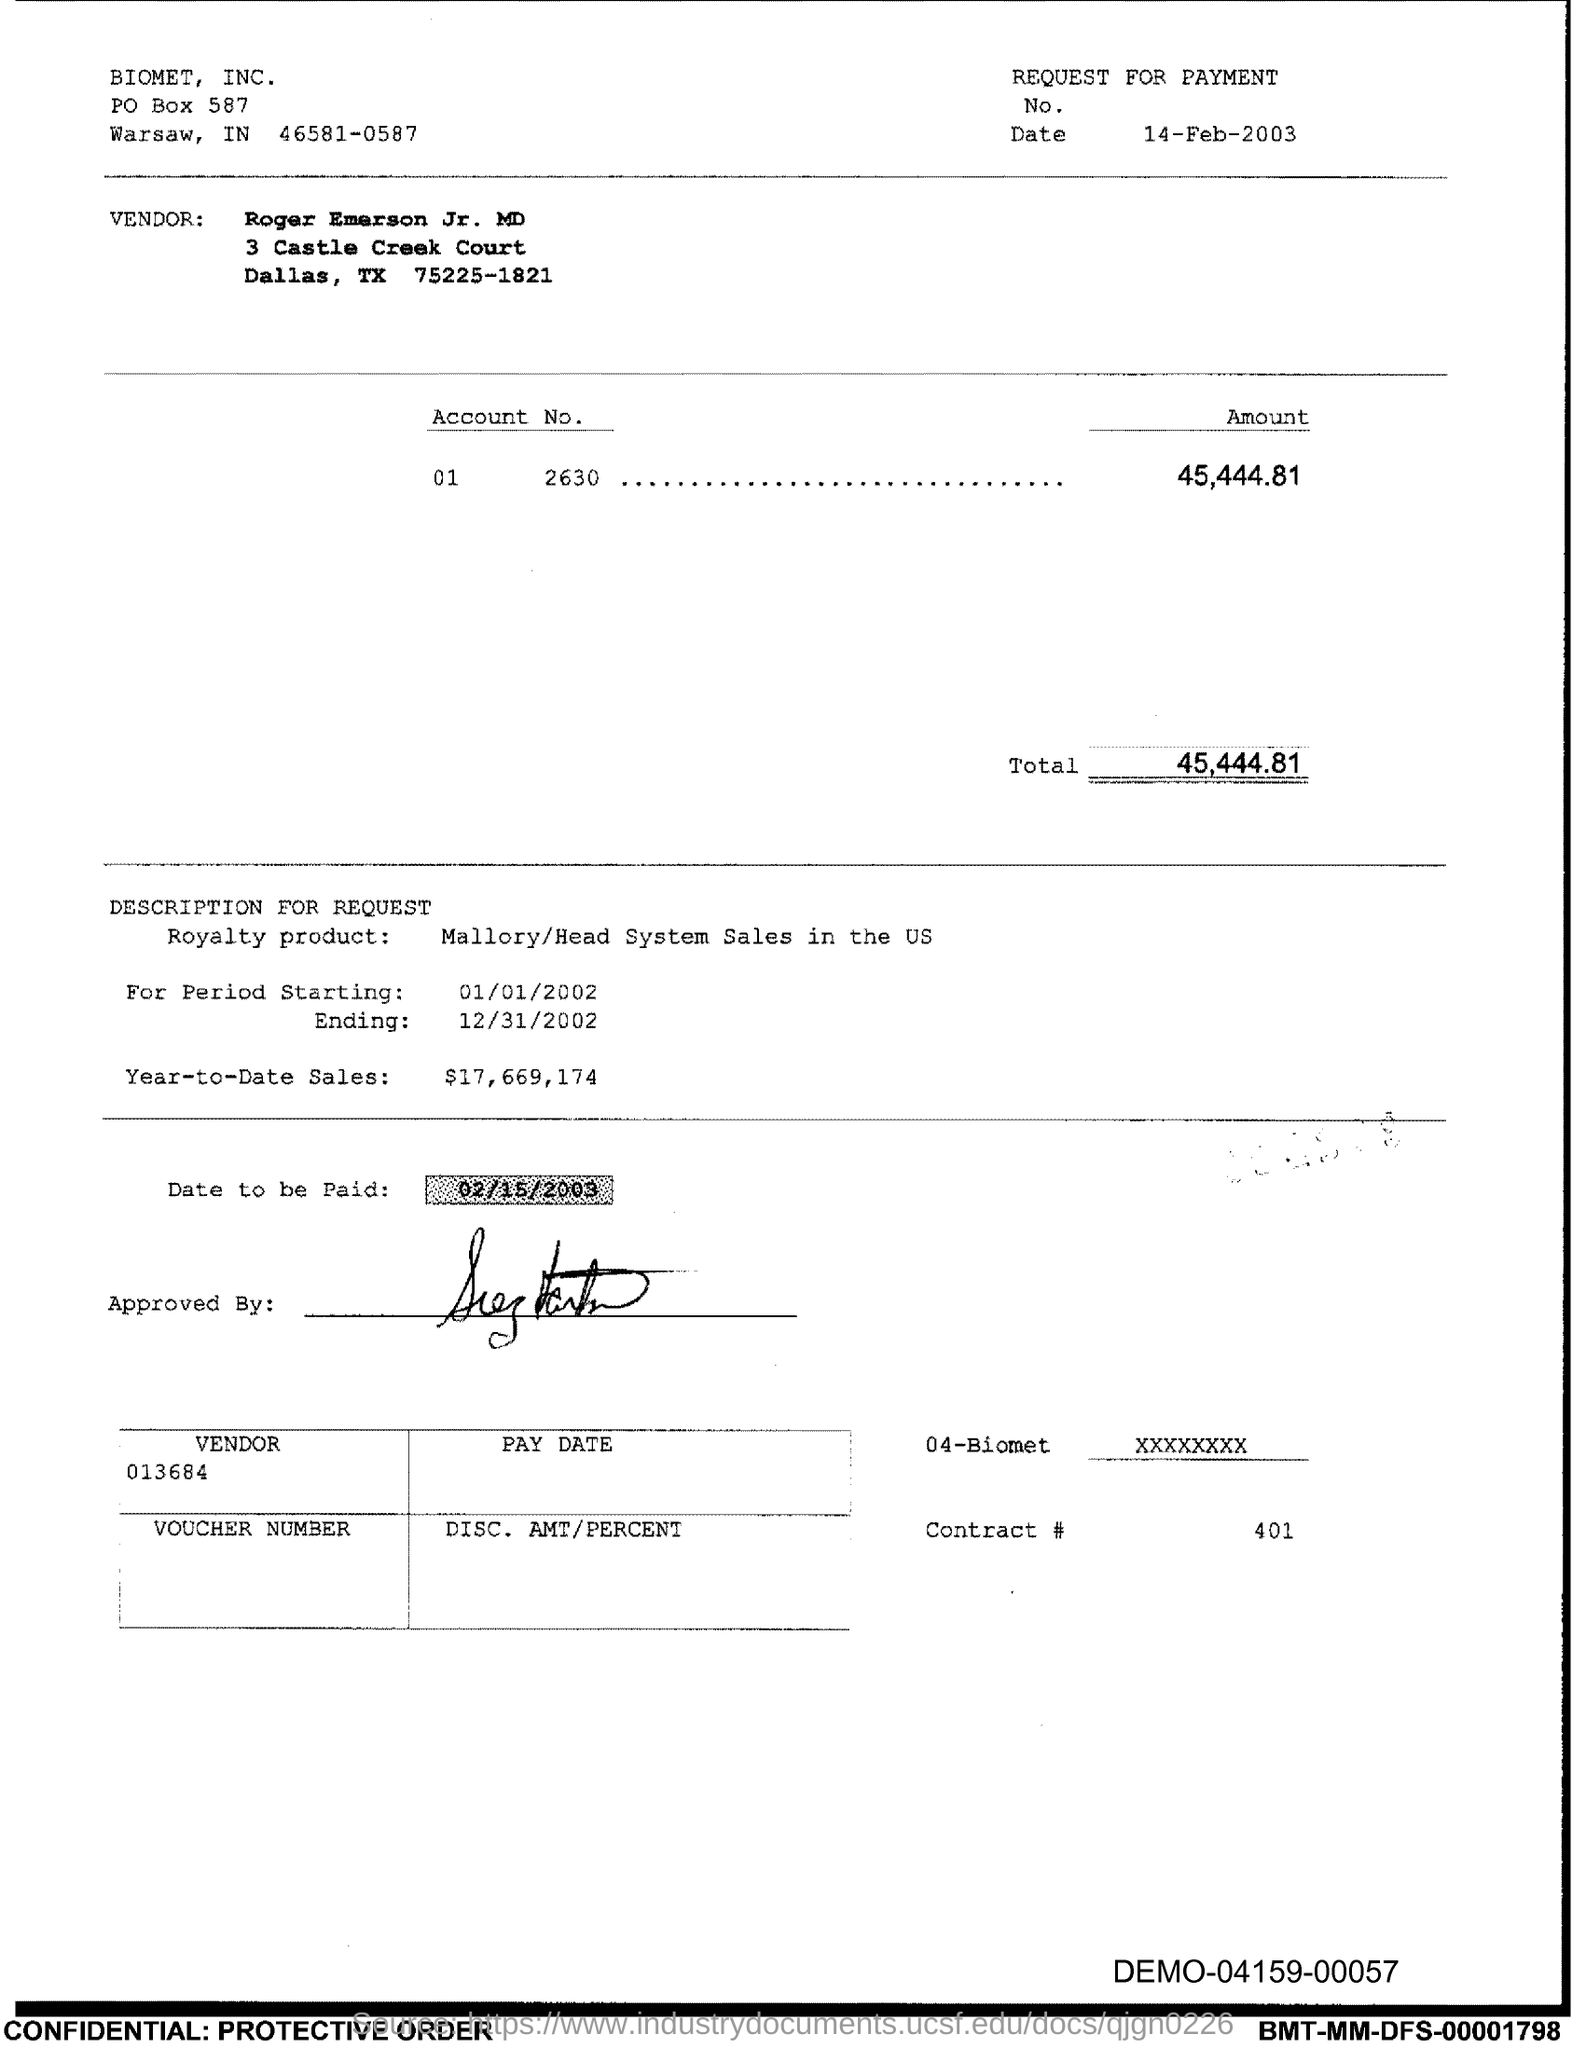What is the Contract # Number? The Contract Number as indicated on the document is 401, located near the bottom of the page under the 'Contract #' label. 